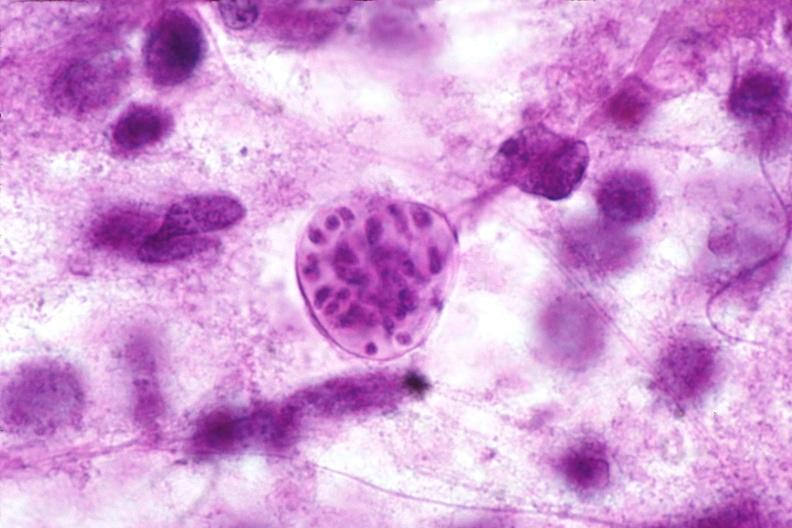does acute peritonitis show brain, toxoplasma encephalitis?
Answer the question using a single word or phrase. No 